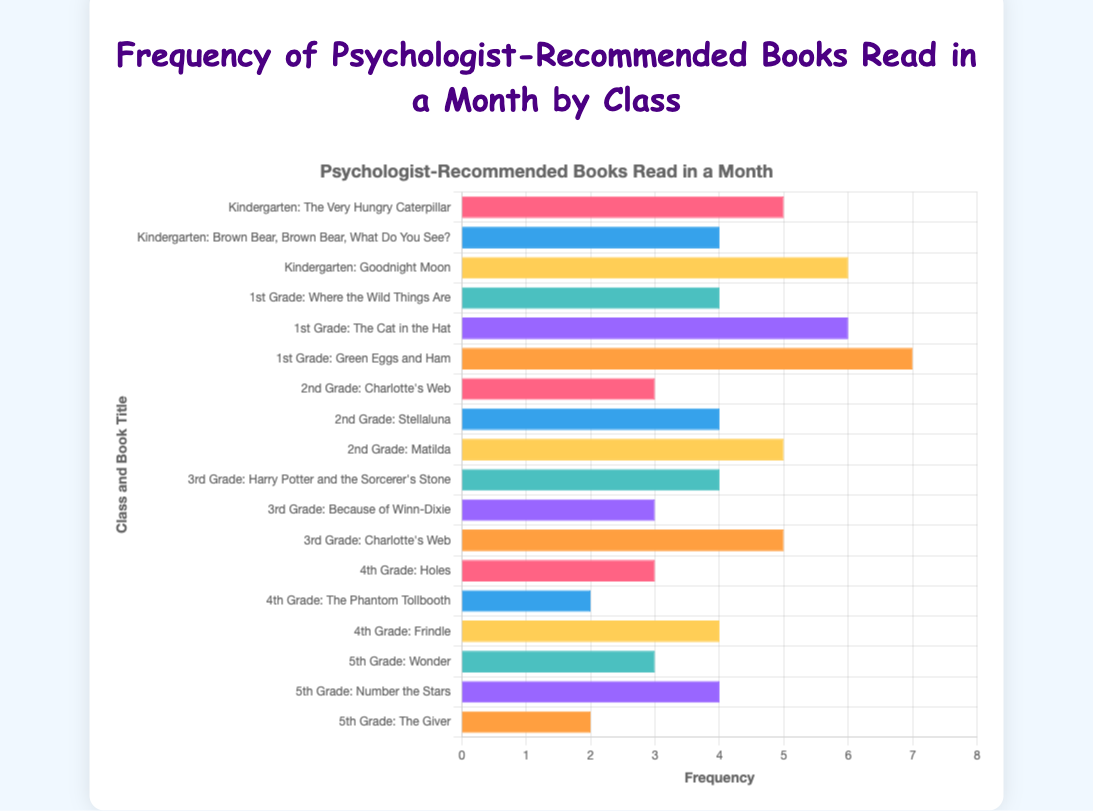What's the most frequently read book in Kindergarten? Find the highest frequency among the books read by the Kindergarten class. "Goodnight Moon" has a frequency of 6, which is the highest.
Answer: Goodnight Moon Which book is read more frequently in 1st Grade: "Where the Wild Things Are" or "The Cat in the Hat"? Compare the frequencies: "Where the Wild Things Are" (4) and "The Cat in the Hat" (6). "The Cat in the Hat" has the higher frequency.
Answer: The Cat in the Hat In 2nd Grade, what is the total number of times the books were read? Sum the reading frequencies of all books in 2nd Grade: 3 ("Charlotte's Web") + 4 ("Stellaluna") + 5 ("Matilda") = 12.
Answer: 12 How does the frequency of reading "Charlotte's Web" compare between 2nd Grade and 3rd Grade? Find the frequencies: 2nd Grade (3), 3rd Grade (5). "Charlotte's Web" is read more frequently in 3rd Grade.
Answer: It's more frequent in 3rd Grade Which class read a book more frequently: "Holes" in 4th Grade or "Wonder" in 5th Grade? Compare the frequencies: "Holes" (3) in 4th Grade and "Wonder" (3) in 5th Grade. Both have the same frequency.
Answer: Both are equal What's the difference in reading frequency between "Matilda" (2nd Grade) and "Harry Potter and the Sorcerer's Stone" (3rd Grade)? Subtract the frequencies: "Matilda" (5) - "Harry Potter and the Sorcerer's Stone" (4) = 1.
Answer: 1 What is the average frequency of books read in Kindergarten? Find the average: (5 + 4 + 6) / 3 = 5.
Answer: 5 Which book is read the least frequently in 1st Grade? Identify the book with the lowest frequency: "Where the Wild Things Are" (4).
Answer: Where the Wild Things Are How many books in total are read 5 or more times across all classes? Count books with frequency ≥ 5: "Goodnight Moon" (6), "The Cat in the Hat" (6), "Green Eggs and Ham" (7), "Matilda" (5), "Charlotte's Web" (3rd Grade) (5). Total is 5 books.
Answer: 5 books Which class has the highest total reading frequency across all their books? Sum the reading frequencies for each class and compare: Kindergarten (15), 1st Grade (17), 2nd Grade (12), 3rd Grade (12), 4th Grade (9), 5th Grade (9). 1st Grade has the highest total.
Answer: 1st Grade 